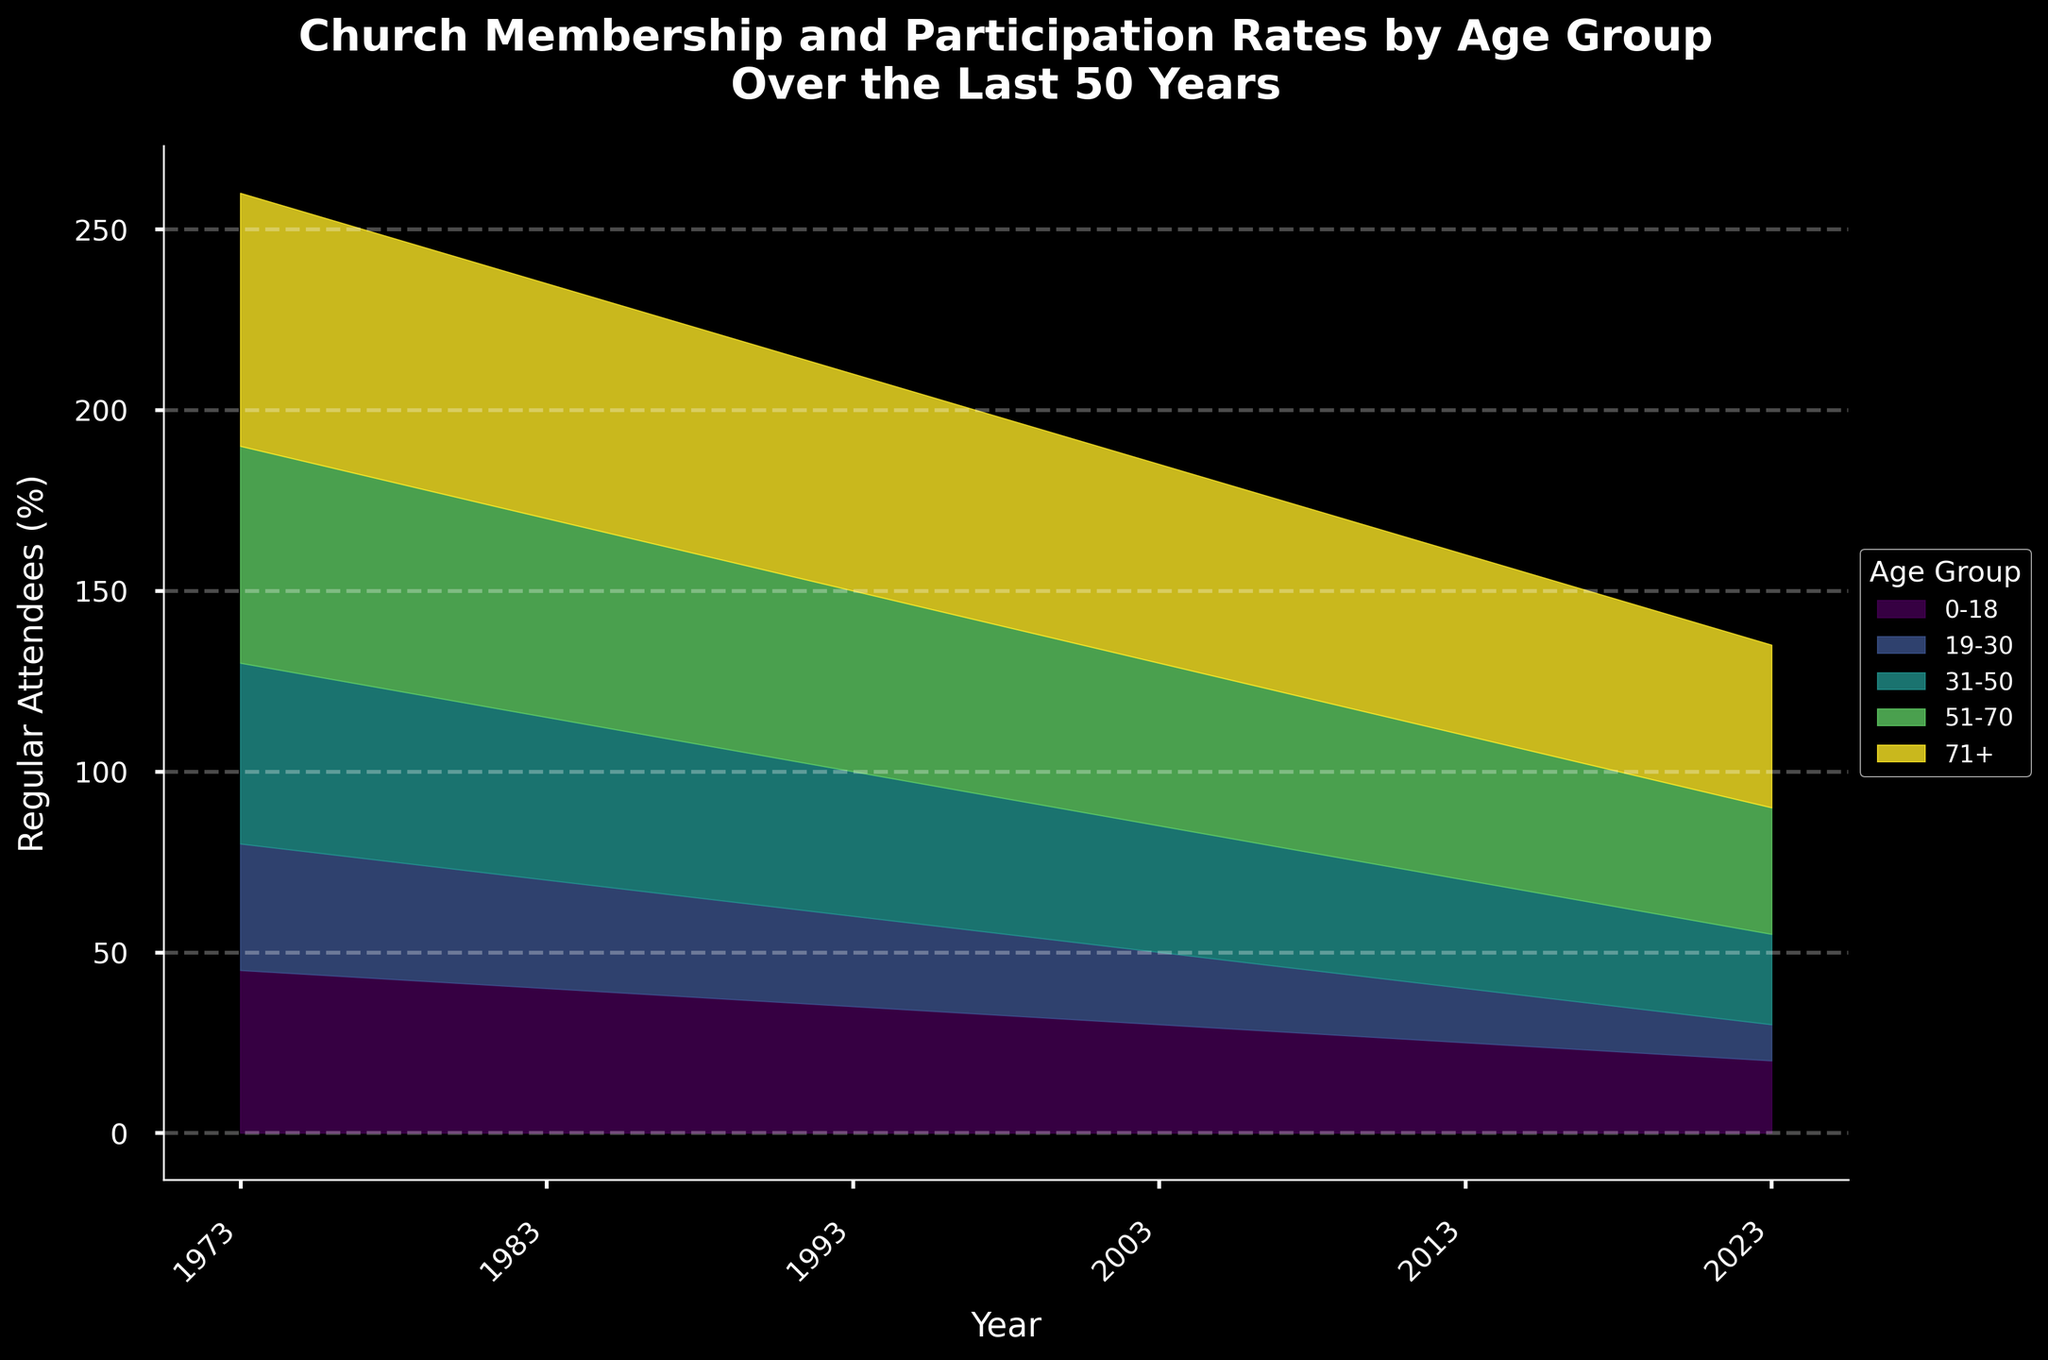What is the title of the figure? The title of the figure is written at the top and describes the content and timespan of the data. It reads "Church Membership and Participation Rates by Age Group Over the Last 50 Years."
Answer: Church Membership and Participation Rates by Age Group Over the Last 50 Years Which age group had the highest percentage of regular attendees in 1973? By looking at the height of the layers for different age groups in 1973, the tallest one represents the age group with the highest percentage of regular attendees. This is the 71+ age group.
Answer: 71+ How does the percentage of regular attendees in the 19-30 age group change from 1973 to 2023? To find the change, compare the values for the 19-30 age group in 1973 and 2023 on the y-axis. In 1973, the percentage was 35%, and in 2023, it is 10%. The change is a decrease of 25%.
Answer: Decreases by 25% What is the overall trend in the percentage of regular attendees for the 0-18 age group over the 50 years? By observing the filled areas for the 0-18 age group across the x-axis, it is apparent that the percentage decreases over time, with values declining from 45% in 1973 to 20% in 2023.
Answer: Decreasing Which age group had the least change in their regular attendance percentage from 1973 to 2023? To determine this, compare the difference between regular attendance percentages in 1973 and 2023 for each age group. The 71+ age group has the smallest change, going from 70% to 45%, a change of 25%.
Answer: 71+ Looking at the stream graph, which age group has the most consistent regular attendance rates over the years? Consistent rates can be identified by a relatively constant width of the stream for an age group over the years. The 51-70 age group shows relatively even participation across the years.
Answer: 51-70 In which decade did the 31-50 age group experience the most significant drop in regular attendance? Observing the stream for the 31-50 age group, the most significant drop appears between 1983 and 1993, where the attendance rate drops from 45% to 40%.
Answer: 1983-1993 Which age group showed an increasing trend in the percentage of occasional attendees from 1973 to 2023? By looking at the layers above the regular attendees for each age group, the 31-50 age group shows an increasing trend in the percentage of occasional attendees over time.
Answer: 31-50 